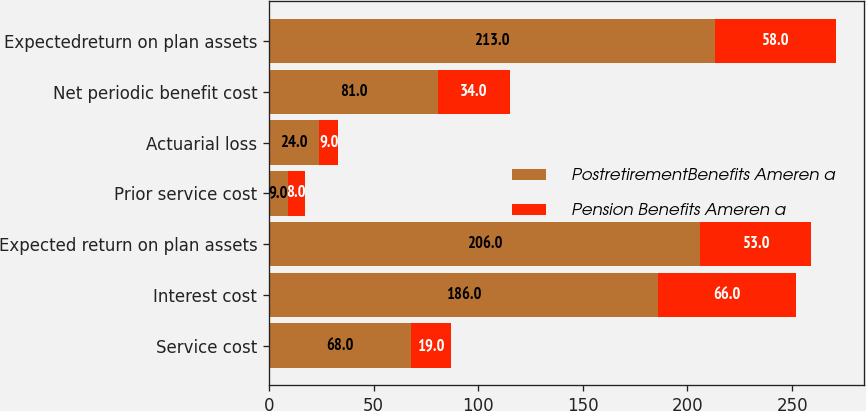Convert chart. <chart><loc_0><loc_0><loc_500><loc_500><stacked_bar_chart><ecel><fcel>Service cost<fcel>Interest cost<fcel>Expected return on plan assets<fcel>Prior service cost<fcel>Actuarial loss<fcel>Net periodic benefit cost<fcel>Expectedreturn on plan assets<nl><fcel>PostretirementBenefits Ameren a<fcel>68<fcel>186<fcel>206<fcel>9<fcel>24<fcel>81<fcel>213<nl><fcel>Pension Benefits Ameren a<fcel>19<fcel>66<fcel>53<fcel>8<fcel>9<fcel>34<fcel>58<nl></chart> 